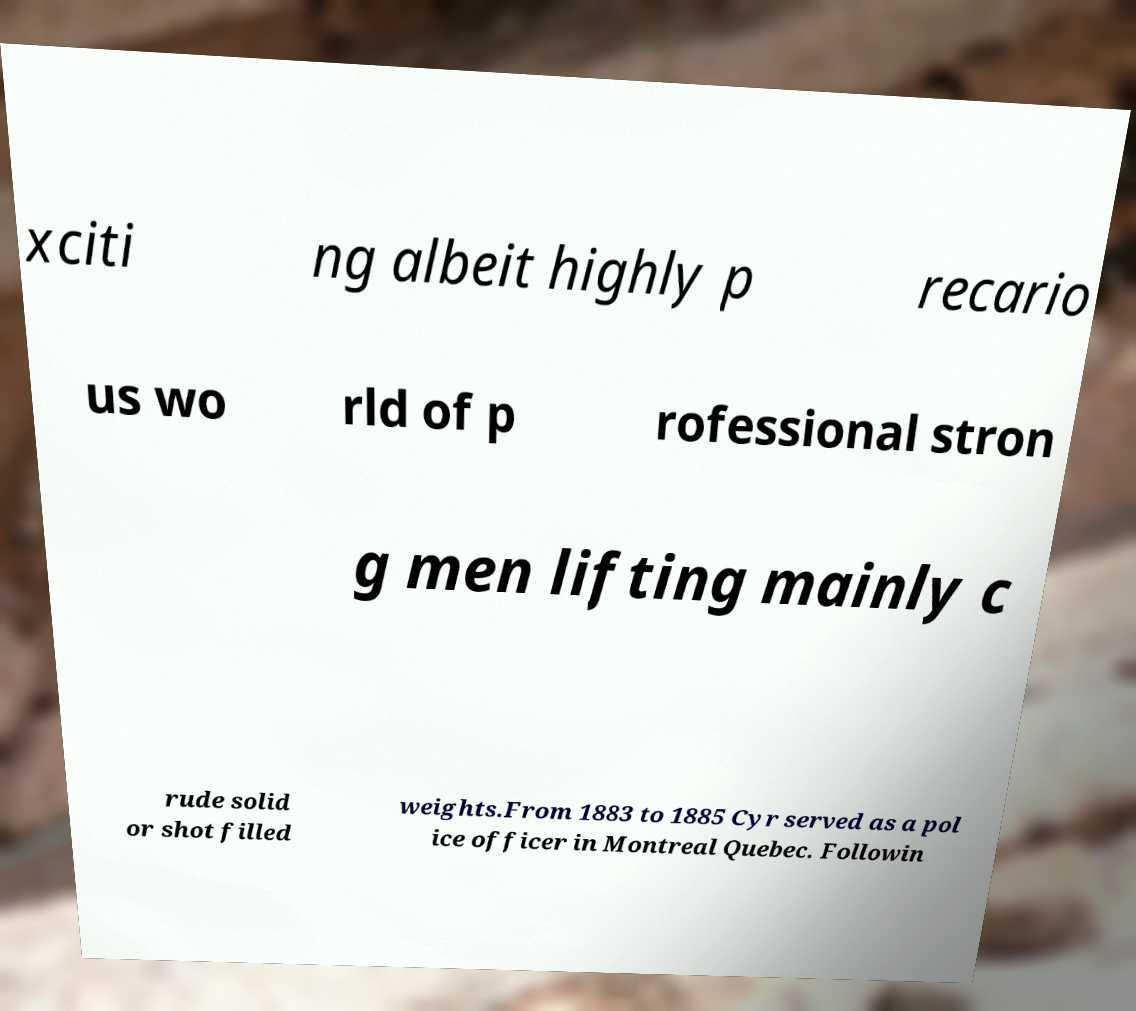Could you assist in decoding the text presented in this image and type it out clearly? xciti ng albeit highly p recario us wo rld of p rofessional stron g men lifting mainly c rude solid or shot filled weights.From 1883 to 1885 Cyr served as a pol ice officer in Montreal Quebec. Followin 